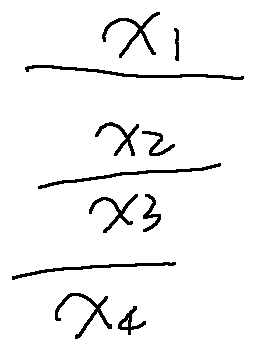<formula> <loc_0><loc_0><loc_500><loc_500>\frac { x _ { 1 } } { \frac { x _ { 2 } } { \frac { x _ { 3 } } { x _ { 4 } } } }</formula> 